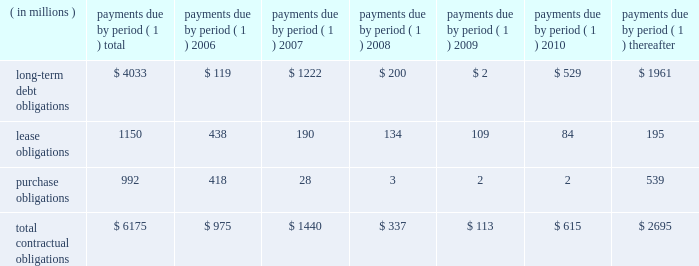57management's discussion and analysis of financial condition and results of operations facility include covenants relating to net interest coverage and total debt-to-book capitalization ratios .
The company was in compliance with the terms of the 3-year credit facility at december 31 , 2005 .
The company has never borrowed under its domestic revolving credit facilities .
Utilization of the non-u.s .
Credit facilities may also be dependent on the company's ability to meet certain conditions at the time a borrowing is requested .
Contractual obligations , guarantees , and other purchase commitments contractual obligations summarized in the table below are the company's obligations and commitments to make future payments under debt obligations ( assuming earliest possible exercise of put rights by holders ) , lease payment obligations , and purchase obligations as of december 31 , 2005 .
Payments due by period ( 1 ) ( in millions ) total 2006 2007 2008 2009 2010 thereafter .
( 1 ) amounts included represent firm , non-cancelable commitments .
Debt obligations : at december 31 , 2005 , the company's long-term debt obligations , including current maturities and unamortized discount and issue costs , totaled $ 4.0 billion , as compared to $ 5.0 billion at december 31 , 2004 .
A table of all outstanding long-term debt securities can be found in note 4 , ""debt and credit facilities'' to the company's consolidated financial statements .
As previously discussed , the decrease in the long- term debt obligations as compared to december 31 , 2004 , was due to the redemptions and repurchases of $ 1.0 billion principal amount of outstanding securities during 2005 .
Also , as previously discussed , the remaining $ 118 million of 7.6% ( 7.6 % ) notes due january 1 , 2007 were reclassified to current maturities of long-term debt .
Lease obligations : the company owns most of its major facilities , but does lease certain office , factory and warehouse space , land , and information technology and other equipment under principally non-cancelable operating leases .
At december 31 , 2005 , future minimum lease obligations , net of minimum sublease rentals , totaled $ 1.2 billion .
Rental expense , net of sublease income , was $ 254 million in 2005 , $ 217 million in 2004 and $ 223 million in 2003 .
Purchase obligations : the company has entered into agreements for the purchase of inventory , license of software , promotional agreements , and research and development agreements which are firm commitments and are not cancelable .
The longest of these agreements extends through 2015 .
Total payments expected to be made under these agreements total $ 992 million .
Commitments under other long-term agreements : the company has entered into certain long-term agreements to purchase software , components , supplies and materials from suppliers .
Most of the agreements extend for periods of one to three years ( three to five years for software ) .
However , generally these agreements do not obligate the company to make any purchases , and many permit the company to terminate the agreement with advance notice ( usually ranging from 60 to 180 days ) .
If the company were to terminate these agreements , it generally would be liable for certain termination charges , typically based on work performed and supplier on-hand inventory and raw materials attributable to canceled orders .
The company's liability would only arise in the event it terminates the agreements for reasons other than ""cause.'' in 2003 , the company entered into outsourcing contracts for certain corporate functions , such as benefit administration and information technology related services .
These contracts generally extend for 10 years and are expected to expire in 2013 .
The total payments under these contracts are approximately $ 3 billion over 10 years ; however , these contracts can be terminated .
Termination would result in a penalty substantially less than the annual contract payments .
The company would also be required to find another source for these services , including the possibility of performing them in-house .
As is customary in bidding for and completing network infrastructure projects and pursuant to a practice the company has followed for many years , the company has a number of performance/bid bonds and standby letters of credit outstanding , primarily relating to projects of government and enterprise mobility solutions segment and the networks segment .
These instruments normally have maturities of up to three years and are standard in the .
What percent of the total contractual obligations should be paid by the end of 2006? 
Computations: (975 / 6175)
Answer: 0.15789. 